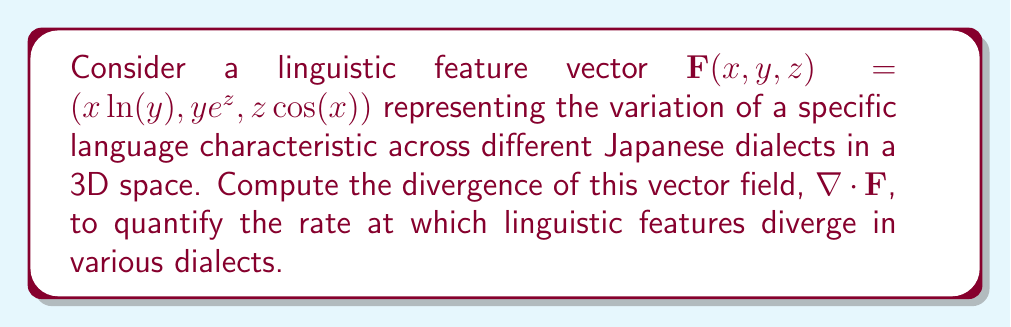What is the answer to this math problem? To compute the divergence of the vector field $\mathbf{F}(x, y, z) = (x\ln(y), ye^z, z\cos(x))$, we need to follow these steps:

1) The divergence is defined as:

   $$\nabla \cdot \mathbf{F} = \frac{\partial F_x}{\partial x} + \frac{\partial F_y}{\partial y} + \frac{\partial F_z}{\partial z}$$

2) Let's calculate each partial derivative:

   a) $F_x = x\ln(y)$
      $$\frac{\partial F_x}{\partial x} = \ln(y)$$

   b) $F_y = ye^z$
      $$\frac{\partial F_y}{\partial y} = e^z$$

   c) $F_z = z\cos(x)$
      $$\frac{\partial F_z}{\partial z} = \cos(x)$$

3) Now, we can substitute these partial derivatives into the divergence formula:

   $$\nabla \cdot \mathbf{F} = \ln(y) + e^z + \cos(x)$$

This expression represents the rate at which linguistic features diverge across different Japanese dialects in the given 3D space.
Answer: $\ln(y) + e^z + \cos(x)$ 